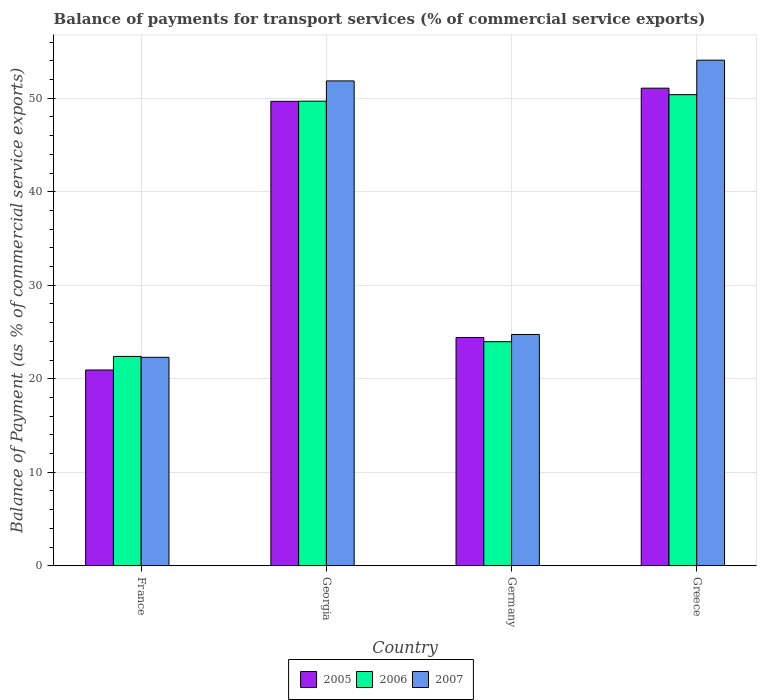How many different coloured bars are there?
Provide a short and direct response. 3. Are the number of bars on each tick of the X-axis equal?
Provide a succinct answer. Yes. How many bars are there on the 1st tick from the right?
Ensure brevity in your answer.  3. What is the label of the 2nd group of bars from the left?
Give a very brief answer. Georgia. What is the balance of payments for transport services in 2007 in Greece?
Provide a short and direct response. 54.07. Across all countries, what is the maximum balance of payments for transport services in 2006?
Your answer should be compact. 50.38. Across all countries, what is the minimum balance of payments for transport services in 2005?
Provide a succinct answer. 20.94. In which country was the balance of payments for transport services in 2006 minimum?
Offer a very short reply. France. What is the total balance of payments for transport services in 2006 in the graph?
Keep it short and to the point. 146.42. What is the difference between the balance of payments for transport services in 2005 in France and that in Georgia?
Your answer should be very brief. -28.73. What is the difference between the balance of payments for transport services in 2007 in Germany and the balance of payments for transport services in 2006 in Georgia?
Keep it short and to the point. -24.95. What is the average balance of payments for transport services in 2005 per country?
Give a very brief answer. 36.53. What is the difference between the balance of payments for transport services of/in 2005 and balance of payments for transport services of/in 2007 in France?
Make the answer very short. -1.36. In how many countries, is the balance of payments for transport services in 2007 greater than 6 %?
Your answer should be compact. 4. What is the ratio of the balance of payments for transport services in 2005 in Georgia to that in Germany?
Your response must be concise. 2.03. What is the difference between the highest and the second highest balance of payments for transport services in 2005?
Make the answer very short. -25.25. What is the difference between the highest and the lowest balance of payments for transport services in 2005?
Ensure brevity in your answer.  30.14. Is the sum of the balance of payments for transport services in 2006 in Georgia and Greece greater than the maximum balance of payments for transport services in 2007 across all countries?
Your answer should be compact. Yes. What does the 2nd bar from the left in France represents?
Make the answer very short. 2006. What does the 2nd bar from the right in France represents?
Offer a very short reply. 2006. Is it the case that in every country, the sum of the balance of payments for transport services in 2007 and balance of payments for transport services in 2006 is greater than the balance of payments for transport services in 2005?
Your answer should be very brief. Yes. Are all the bars in the graph horizontal?
Provide a short and direct response. No. Where does the legend appear in the graph?
Keep it short and to the point. Bottom center. What is the title of the graph?
Your answer should be compact. Balance of payments for transport services (% of commercial service exports). What is the label or title of the X-axis?
Offer a terse response. Country. What is the label or title of the Y-axis?
Keep it short and to the point. Balance of Payment (as % of commercial service exports). What is the Balance of Payment (as % of commercial service exports) of 2005 in France?
Your response must be concise. 20.94. What is the Balance of Payment (as % of commercial service exports) in 2006 in France?
Offer a very short reply. 22.39. What is the Balance of Payment (as % of commercial service exports) in 2007 in France?
Your answer should be compact. 22.29. What is the Balance of Payment (as % of commercial service exports) in 2005 in Georgia?
Your answer should be very brief. 49.67. What is the Balance of Payment (as % of commercial service exports) in 2006 in Georgia?
Your response must be concise. 49.69. What is the Balance of Payment (as % of commercial service exports) in 2007 in Georgia?
Your answer should be compact. 51.85. What is the Balance of Payment (as % of commercial service exports) of 2005 in Germany?
Keep it short and to the point. 24.42. What is the Balance of Payment (as % of commercial service exports) in 2006 in Germany?
Your response must be concise. 23.97. What is the Balance of Payment (as % of commercial service exports) of 2007 in Germany?
Make the answer very short. 24.74. What is the Balance of Payment (as % of commercial service exports) in 2005 in Greece?
Your response must be concise. 51.08. What is the Balance of Payment (as % of commercial service exports) in 2006 in Greece?
Your answer should be compact. 50.38. What is the Balance of Payment (as % of commercial service exports) of 2007 in Greece?
Your response must be concise. 54.07. Across all countries, what is the maximum Balance of Payment (as % of commercial service exports) in 2005?
Make the answer very short. 51.08. Across all countries, what is the maximum Balance of Payment (as % of commercial service exports) in 2006?
Keep it short and to the point. 50.38. Across all countries, what is the maximum Balance of Payment (as % of commercial service exports) of 2007?
Make the answer very short. 54.07. Across all countries, what is the minimum Balance of Payment (as % of commercial service exports) of 2005?
Your answer should be compact. 20.94. Across all countries, what is the minimum Balance of Payment (as % of commercial service exports) in 2006?
Make the answer very short. 22.39. Across all countries, what is the minimum Balance of Payment (as % of commercial service exports) of 2007?
Provide a short and direct response. 22.29. What is the total Balance of Payment (as % of commercial service exports) of 2005 in the graph?
Offer a very short reply. 146.1. What is the total Balance of Payment (as % of commercial service exports) of 2006 in the graph?
Ensure brevity in your answer.  146.42. What is the total Balance of Payment (as % of commercial service exports) in 2007 in the graph?
Provide a short and direct response. 152.96. What is the difference between the Balance of Payment (as % of commercial service exports) of 2005 in France and that in Georgia?
Make the answer very short. -28.73. What is the difference between the Balance of Payment (as % of commercial service exports) of 2006 in France and that in Georgia?
Your answer should be very brief. -27.3. What is the difference between the Balance of Payment (as % of commercial service exports) in 2007 in France and that in Georgia?
Your response must be concise. -29.56. What is the difference between the Balance of Payment (as % of commercial service exports) of 2005 in France and that in Germany?
Make the answer very short. -3.48. What is the difference between the Balance of Payment (as % of commercial service exports) of 2006 in France and that in Germany?
Your response must be concise. -1.58. What is the difference between the Balance of Payment (as % of commercial service exports) in 2007 in France and that in Germany?
Provide a short and direct response. -2.44. What is the difference between the Balance of Payment (as % of commercial service exports) of 2005 in France and that in Greece?
Ensure brevity in your answer.  -30.14. What is the difference between the Balance of Payment (as % of commercial service exports) of 2006 in France and that in Greece?
Offer a very short reply. -27.99. What is the difference between the Balance of Payment (as % of commercial service exports) of 2007 in France and that in Greece?
Offer a very short reply. -31.78. What is the difference between the Balance of Payment (as % of commercial service exports) of 2005 in Georgia and that in Germany?
Provide a succinct answer. 25.25. What is the difference between the Balance of Payment (as % of commercial service exports) of 2006 in Georgia and that in Germany?
Make the answer very short. 25.72. What is the difference between the Balance of Payment (as % of commercial service exports) of 2007 in Georgia and that in Germany?
Offer a very short reply. 27.12. What is the difference between the Balance of Payment (as % of commercial service exports) in 2005 in Georgia and that in Greece?
Your response must be concise. -1.41. What is the difference between the Balance of Payment (as % of commercial service exports) in 2006 in Georgia and that in Greece?
Provide a succinct answer. -0.7. What is the difference between the Balance of Payment (as % of commercial service exports) of 2007 in Georgia and that in Greece?
Provide a succinct answer. -2.22. What is the difference between the Balance of Payment (as % of commercial service exports) of 2005 in Germany and that in Greece?
Offer a terse response. -26.66. What is the difference between the Balance of Payment (as % of commercial service exports) of 2006 in Germany and that in Greece?
Your answer should be very brief. -26.41. What is the difference between the Balance of Payment (as % of commercial service exports) in 2007 in Germany and that in Greece?
Make the answer very short. -29.34. What is the difference between the Balance of Payment (as % of commercial service exports) of 2005 in France and the Balance of Payment (as % of commercial service exports) of 2006 in Georgia?
Offer a terse response. -28.75. What is the difference between the Balance of Payment (as % of commercial service exports) in 2005 in France and the Balance of Payment (as % of commercial service exports) in 2007 in Georgia?
Offer a terse response. -30.91. What is the difference between the Balance of Payment (as % of commercial service exports) of 2006 in France and the Balance of Payment (as % of commercial service exports) of 2007 in Georgia?
Provide a succinct answer. -29.46. What is the difference between the Balance of Payment (as % of commercial service exports) of 2005 in France and the Balance of Payment (as % of commercial service exports) of 2006 in Germany?
Provide a short and direct response. -3.03. What is the difference between the Balance of Payment (as % of commercial service exports) of 2005 in France and the Balance of Payment (as % of commercial service exports) of 2007 in Germany?
Your answer should be compact. -3.8. What is the difference between the Balance of Payment (as % of commercial service exports) of 2006 in France and the Balance of Payment (as % of commercial service exports) of 2007 in Germany?
Provide a succinct answer. -2.35. What is the difference between the Balance of Payment (as % of commercial service exports) of 2005 in France and the Balance of Payment (as % of commercial service exports) of 2006 in Greece?
Ensure brevity in your answer.  -29.44. What is the difference between the Balance of Payment (as % of commercial service exports) in 2005 in France and the Balance of Payment (as % of commercial service exports) in 2007 in Greece?
Offer a terse response. -33.13. What is the difference between the Balance of Payment (as % of commercial service exports) of 2006 in France and the Balance of Payment (as % of commercial service exports) of 2007 in Greece?
Make the answer very short. -31.68. What is the difference between the Balance of Payment (as % of commercial service exports) of 2005 in Georgia and the Balance of Payment (as % of commercial service exports) of 2006 in Germany?
Offer a terse response. 25.7. What is the difference between the Balance of Payment (as % of commercial service exports) of 2005 in Georgia and the Balance of Payment (as % of commercial service exports) of 2007 in Germany?
Offer a very short reply. 24.93. What is the difference between the Balance of Payment (as % of commercial service exports) in 2006 in Georgia and the Balance of Payment (as % of commercial service exports) in 2007 in Germany?
Provide a short and direct response. 24.95. What is the difference between the Balance of Payment (as % of commercial service exports) in 2005 in Georgia and the Balance of Payment (as % of commercial service exports) in 2006 in Greece?
Offer a terse response. -0.71. What is the difference between the Balance of Payment (as % of commercial service exports) in 2005 in Georgia and the Balance of Payment (as % of commercial service exports) in 2007 in Greece?
Keep it short and to the point. -4.4. What is the difference between the Balance of Payment (as % of commercial service exports) in 2006 in Georgia and the Balance of Payment (as % of commercial service exports) in 2007 in Greece?
Give a very brief answer. -4.39. What is the difference between the Balance of Payment (as % of commercial service exports) of 2005 in Germany and the Balance of Payment (as % of commercial service exports) of 2006 in Greece?
Ensure brevity in your answer.  -25.97. What is the difference between the Balance of Payment (as % of commercial service exports) of 2005 in Germany and the Balance of Payment (as % of commercial service exports) of 2007 in Greece?
Provide a short and direct response. -29.66. What is the difference between the Balance of Payment (as % of commercial service exports) of 2006 in Germany and the Balance of Payment (as % of commercial service exports) of 2007 in Greece?
Provide a succinct answer. -30.11. What is the average Balance of Payment (as % of commercial service exports) in 2005 per country?
Make the answer very short. 36.53. What is the average Balance of Payment (as % of commercial service exports) of 2006 per country?
Keep it short and to the point. 36.61. What is the average Balance of Payment (as % of commercial service exports) of 2007 per country?
Make the answer very short. 38.24. What is the difference between the Balance of Payment (as % of commercial service exports) in 2005 and Balance of Payment (as % of commercial service exports) in 2006 in France?
Your answer should be compact. -1.45. What is the difference between the Balance of Payment (as % of commercial service exports) of 2005 and Balance of Payment (as % of commercial service exports) of 2007 in France?
Keep it short and to the point. -1.36. What is the difference between the Balance of Payment (as % of commercial service exports) of 2006 and Balance of Payment (as % of commercial service exports) of 2007 in France?
Provide a succinct answer. 0.1. What is the difference between the Balance of Payment (as % of commercial service exports) of 2005 and Balance of Payment (as % of commercial service exports) of 2006 in Georgia?
Provide a succinct answer. -0.02. What is the difference between the Balance of Payment (as % of commercial service exports) of 2005 and Balance of Payment (as % of commercial service exports) of 2007 in Georgia?
Offer a very short reply. -2.18. What is the difference between the Balance of Payment (as % of commercial service exports) of 2006 and Balance of Payment (as % of commercial service exports) of 2007 in Georgia?
Provide a succinct answer. -2.17. What is the difference between the Balance of Payment (as % of commercial service exports) in 2005 and Balance of Payment (as % of commercial service exports) in 2006 in Germany?
Give a very brief answer. 0.45. What is the difference between the Balance of Payment (as % of commercial service exports) in 2005 and Balance of Payment (as % of commercial service exports) in 2007 in Germany?
Give a very brief answer. -0.32. What is the difference between the Balance of Payment (as % of commercial service exports) of 2006 and Balance of Payment (as % of commercial service exports) of 2007 in Germany?
Ensure brevity in your answer.  -0.77. What is the difference between the Balance of Payment (as % of commercial service exports) in 2005 and Balance of Payment (as % of commercial service exports) in 2006 in Greece?
Give a very brief answer. 0.7. What is the difference between the Balance of Payment (as % of commercial service exports) in 2005 and Balance of Payment (as % of commercial service exports) in 2007 in Greece?
Your response must be concise. -2.99. What is the difference between the Balance of Payment (as % of commercial service exports) of 2006 and Balance of Payment (as % of commercial service exports) of 2007 in Greece?
Give a very brief answer. -3.69. What is the ratio of the Balance of Payment (as % of commercial service exports) in 2005 in France to that in Georgia?
Offer a terse response. 0.42. What is the ratio of the Balance of Payment (as % of commercial service exports) of 2006 in France to that in Georgia?
Provide a short and direct response. 0.45. What is the ratio of the Balance of Payment (as % of commercial service exports) of 2007 in France to that in Georgia?
Give a very brief answer. 0.43. What is the ratio of the Balance of Payment (as % of commercial service exports) in 2005 in France to that in Germany?
Give a very brief answer. 0.86. What is the ratio of the Balance of Payment (as % of commercial service exports) in 2006 in France to that in Germany?
Your answer should be compact. 0.93. What is the ratio of the Balance of Payment (as % of commercial service exports) of 2007 in France to that in Germany?
Ensure brevity in your answer.  0.9. What is the ratio of the Balance of Payment (as % of commercial service exports) of 2005 in France to that in Greece?
Provide a succinct answer. 0.41. What is the ratio of the Balance of Payment (as % of commercial service exports) of 2006 in France to that in Greece?
Make the answer very short. 0.44. What is the ratio of the Balance of Payment (as % of commercial service exports) of 2007 in France to that in Greece?
Keep it short and to the point. 0.41. What is the ratio of the Balance of Payment (as % of commercial service exports) of 2005 in Georgia to that in Germany?
Your response must be concise. 2.03. What is the ratio of the Balance of Payment (as % of commercial service exports) of 2006 in Georgia to that in Germany?
Offer a very short reply. 2.07. What is the ratio of the Balance of Payment (as % of commercial service exports) of 2007 in Georgia to that in Germany?
Your answer should be very brief. 2.1. What is the ratio of the Balance of Payment (as % of commercial service exports) in 2005 in Georgia to that in Greece?
Your response must be concise. 0.97. What is the ratio of the Balance of Payment (as % of commercial service exports) of 2006 in Georgia to that in Greece?
Provide a short and direct response. 0.99. What is the ratio of the Balance of Payment (as % of commercial service exports) of 2005 in Germany to that in Greece?
Ensure brevity in your answer.  0.48. What is the ratio of the Balance of Payment (as % of commercial service exports) in 2006 in Germany to that in Greece?
Your answer should be compact. 0.48. What is the ratio of the Balance of Payment (as % of commercial service exports) of 2007 in Germany to that in Greece?
Your answer should be very brief. 0.46. What is the difference between the highest and the second highest Balance of Payment (as % of commercial service exports) in 2005?
Your answer should be very brief. 1.41. What is the difference between the highest and the second highest Balance of Payment (as % of commercial service exports) of 2006?
Your response must be concise. 0.7. What is the difference between the highest and the second highest Balance of Payment (as % of commercial service exports) of 2007?
Keep it short and to the point. 2.22. What is the difference between the highest and the lowest Balance of Payment (as % of commercial service exports) in 2005?
Your answer should be compact. 30.14. What is the difference between the highest and the lowest Balance of Payment (as % of commercial service exports) of 2006?
Your response must be concise. 27.99. What is the difference between the highest and the lowest Balance of Payment (as % of commercial service exports) in 2007?
Ensure brevity in your answer.  31.78. 